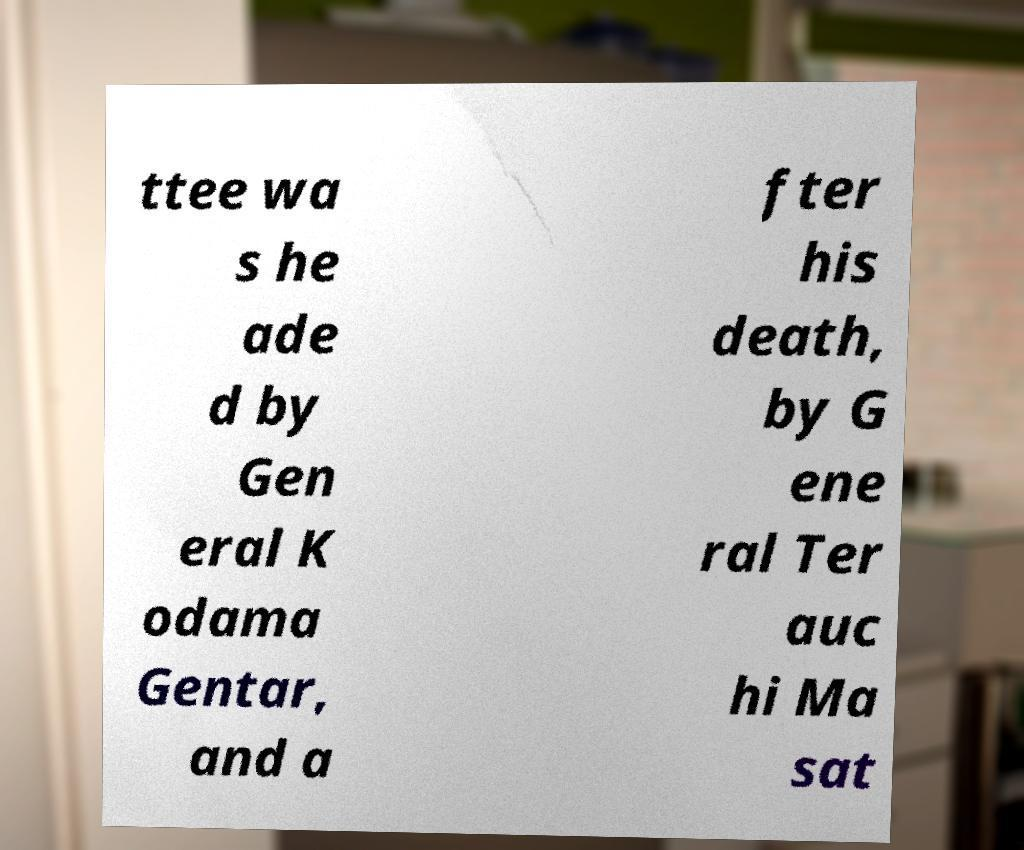What messages or text are displayed in this image? I need them in a readable, typed format. ttee wa s he ade d by Gen eral K odama Gentar, and a fter his death, by G ene ral Ter auc hi Ma sat 